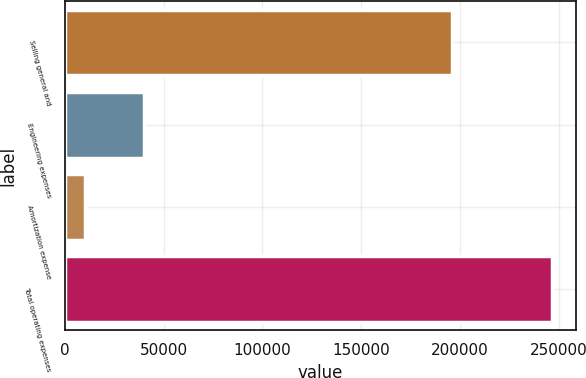Convert chart. <chart><loc_0><loc_0><loc_500><loc_500><bar_chart><fcel>Selling general and<fcel>Engineering expenses<fcel>Amortization expense<fcel>Total operating expenses<nl><fcel>195892<fcel>40203<fcel>10173<fcel>246268<nl></chart> 